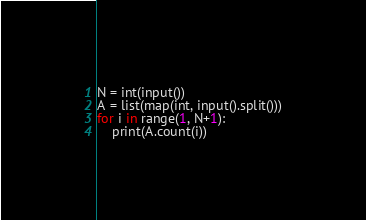Convert code to text. <code><loc_0><loc_0><loc_500><loc_500><_Python_>N = int(input())
A = list(map(int, input().split()))
for i in range(1, N+1):
    print(A.count(i))</code> 